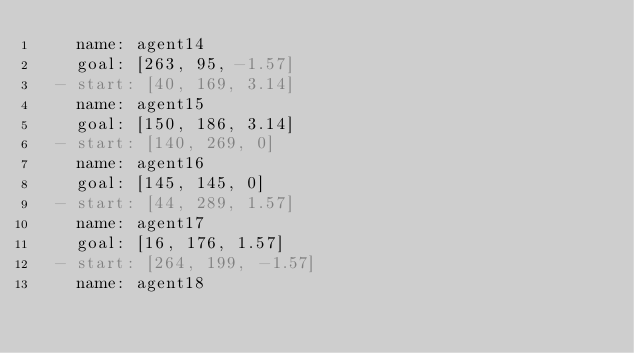Convert code to text. <code><loc_0><loc_0><loc_500><loc_500><_YAML_>    name: agent14
    goal: [263, 95, -1.57]
  - start: [40, 169, 3.14]
    name: agent15
    goal: [150, 186, 3.14]
  - start: [140, 269, 0]
    name: agent16
    goal: [145, 145, 0]
  - start: [44, 289, 1.57]
    name: agent17
    goal: [16, 176, 1.57]
  - start: [264, 199, -1.57]
    name: agent18</code> 